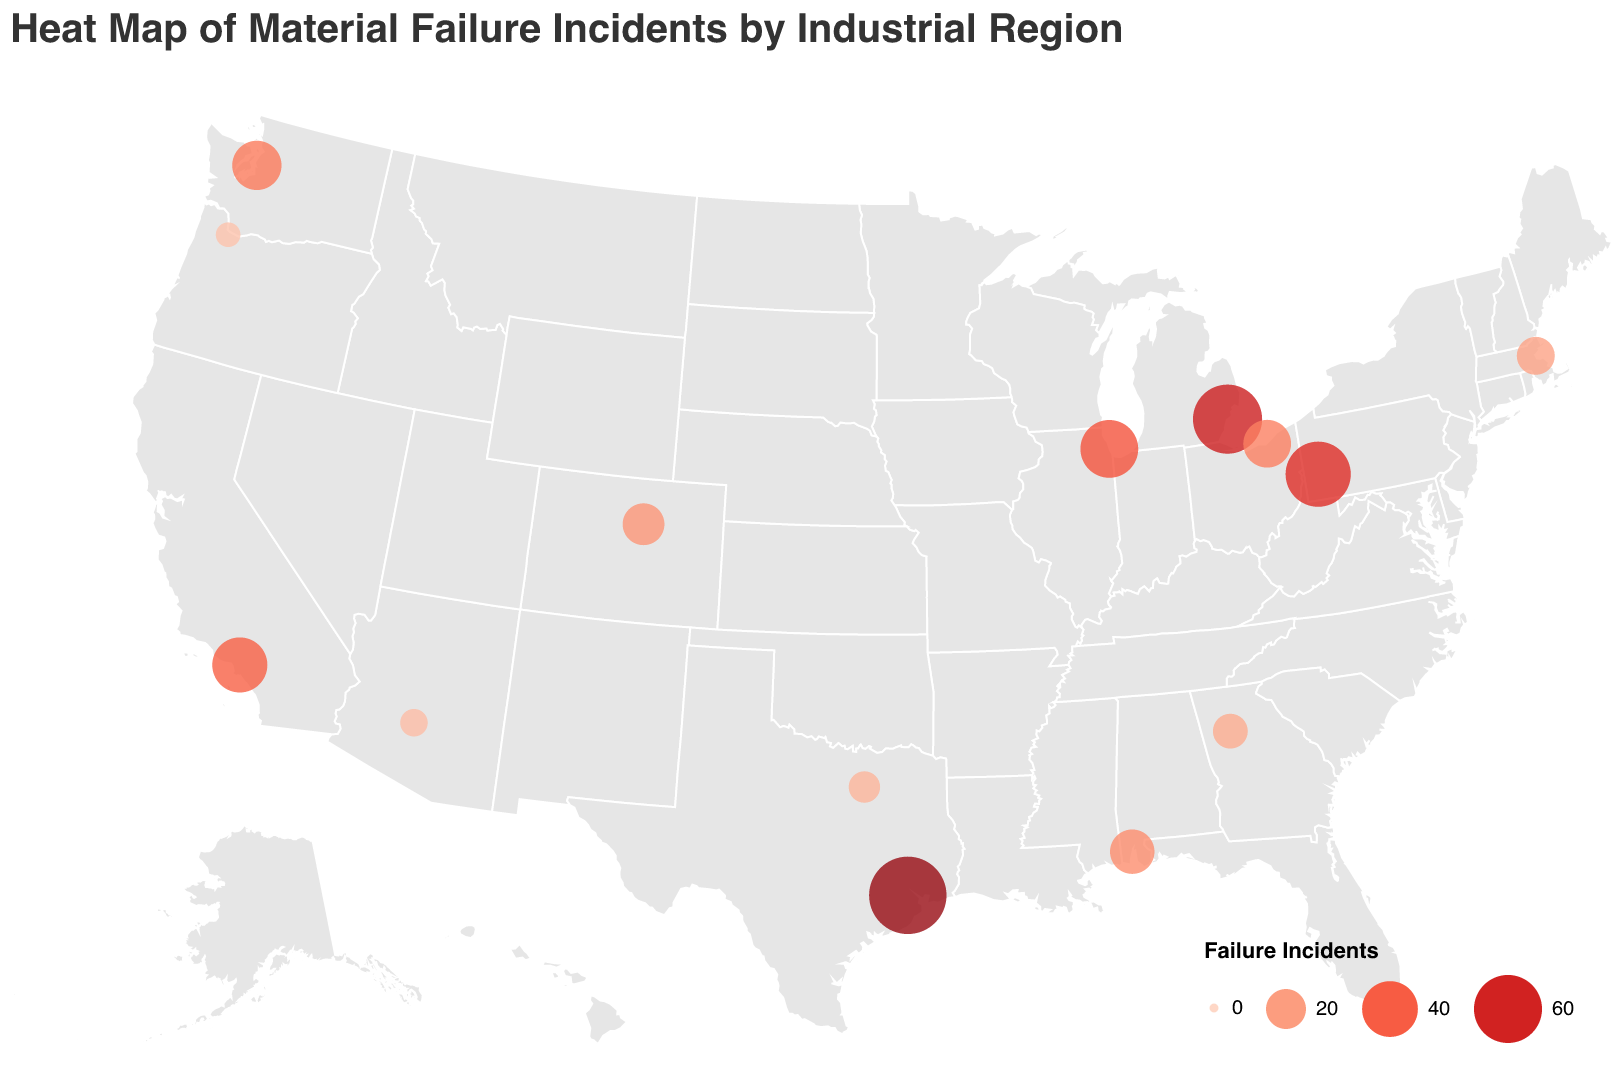What's the title of the figure? The title of the figure is displayed prominently at the top in the font "Helvetica" and with a font size of 20. It reads "Heat Map of Material Failure Incidents by Industrial Region".
Answer: Heat Map of Material Failure Incidents by Industrial Region Which region has the highest number of material failure incidents? By looking at the size and color intensity of the circles in the map, the largest and darkest red circle represents Houston, indicating it has the highest number of material failure incidents.
Answer: Houston How many material failure incidents are reported in Boston? Hovering over or looking at the tooltip for the circle representing Boston reveals that it has 18 material failure incidents.
Answer: 18 What's the total number of material failure incidents reported in Houston, Detroit, and Pittsburgh? Adding the failure incidents for Houston (78), Detroit (62), and Pittsburgh (55), the total is 78 + 62 + 55 = 195.
Answer: 195 Compare the number of material failure incidents between Miami and Phoenix. Which region has more and by how much? Miami has 5 incidents, and Phoenix has 9 incidents. Phoenix has 4 more incidents than Miami. The difference is calculated as 9 - 5 = 4.
Answer: Phoenix, by 4 incidents What is the average number of material failure incidents across all regions depicted? Sum all incidents: 78 + 62 + 55 + 43 + 39 + 31 + 29 + 25 + 22 + 18 + 15 + 12 + 9 + 7 + 5 = 450. There are 15 regions, so the average is 450 / 15 = 30.
Answer: 30 Which regions have fewer than 10 material failure incidents? By referring to the size and tooltip of the circles, Phoenix (9), Portland (7), and Miami (5) have fewer than 10 material failure incidents.
Answer: Phoenix, Portland, Miami What is the total number of material failure incidents in the regions located in the state of California? Los Angeles is the only region in California on the map, with 39 material failure incidents.
Answer: 39 Explain the color scheme used in the heat map. The color intensity indicates the number of material failure incidents, with darker red representing higher incidents. The tooltip and legend confirm this, showing a gradient from lighter to darker red corresponding to fewer to more incidents.
Answer: Darker red = Higher incidents, Lighter red = Fewer incidents 